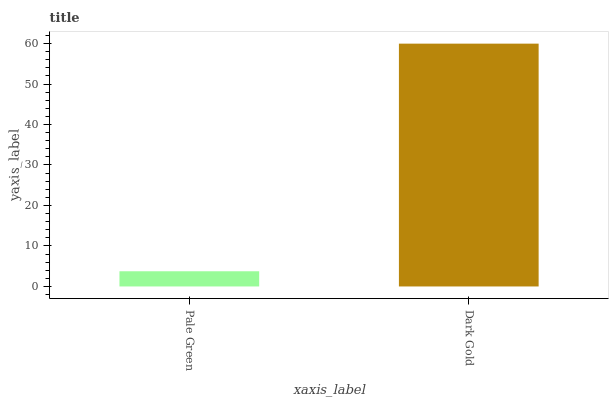Is Pale Green the minimum?
Answer yes or no. Yes. Is Dark Gold the maximum?
Answer yes or no. Yes. Is Dark Gold the minimum?
Answer yes or no. No. Is Dark Gold greater than Pale Green?
Answer yes or no. Yes. Is Pale Green less than Dark Gold?
Answer yes or no. Yes. Is Pale Green greater than Dark Gold?
Answer yes or no. No. Is Dark Gold less than Pale Green?
Answer yes or no. No. Is Dark Gold the high median?
Answer yes or no. Yes. Is Pale Green the low median?
Answer yes or no. Yes. Is Pale Green the high median?
Answer yes or no. No. Is Dark Gold the low median?
Answer yes or no. No. 